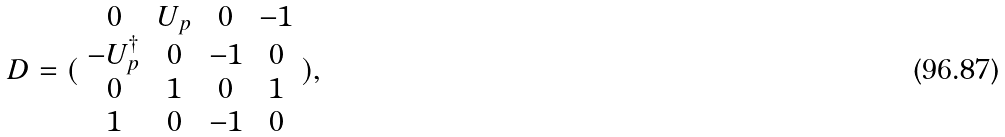<formula> <loc_0><loc_0><loc_500><loc_500>D = ( \begin{array} { c c c c } 0 & U _ { p } & 0 & - 1 \\ - U _ { p } ^ { \dagger } & 0 & - 1 & 0 \\ 0 & 1 & 0 & 1 \\ 1 & 0 & - 1 & 0 \end{array} ) ,</formula> 